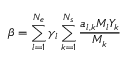<formula> <loc_0><loc_0><loc_500><loc_500>\beta = \sum _ { l = 1 } ^ { N _ { e } } \gamma _ { l } \sum _ { k = 1 } ^ { N _ { s } } \frac { a _ { l , k } M _ { l } Y _ { k } } { M _ { k } }</formula> 